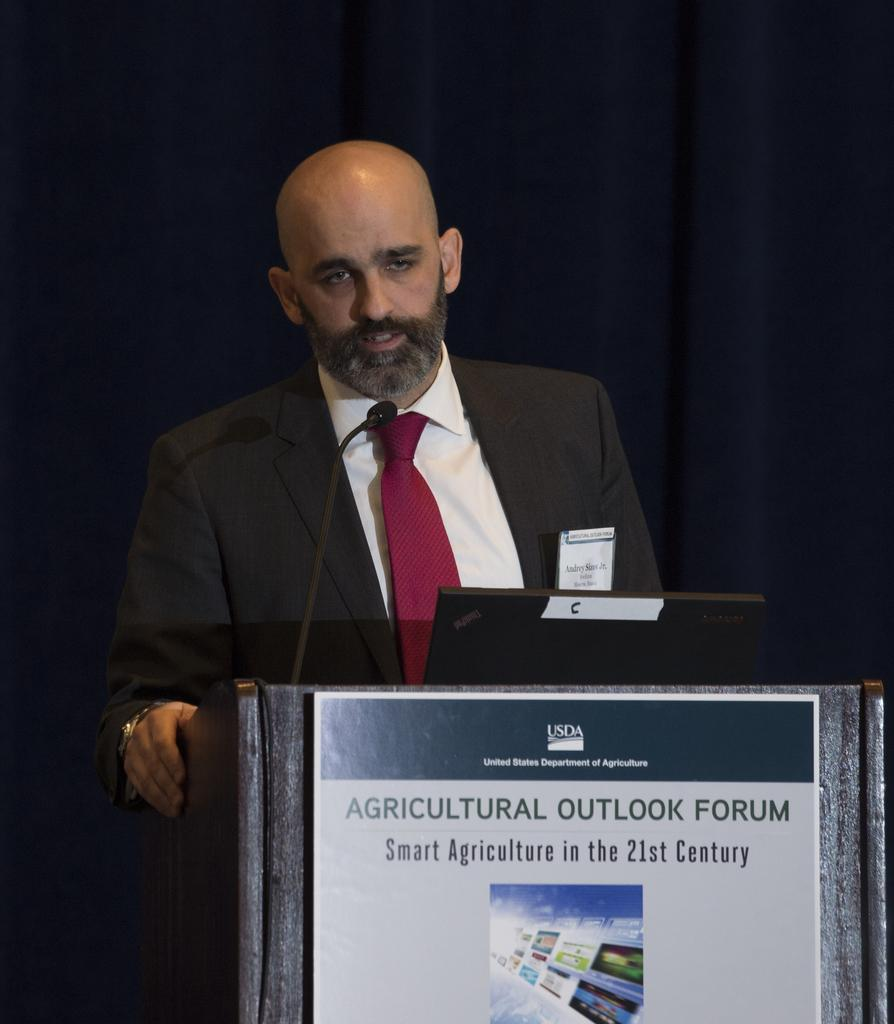What device is present in the image for amplifying sound? There is a microphone in the image for amplifying sound. What electronic device is also visible in the image? There is a laptop in the image. Where are the microphone and laptop located in the image? Both the microphone and laptop are on a podium. What is attached to the podium in the image? There is a board attached to the podium. Can you describe the person in the image? A person is standing in the image. What type of window treatment is visible in the image? There are curtains visible in the image. What type of bag is the person holding in the image? There is no bag visible in the image; the person is not holding anything. 